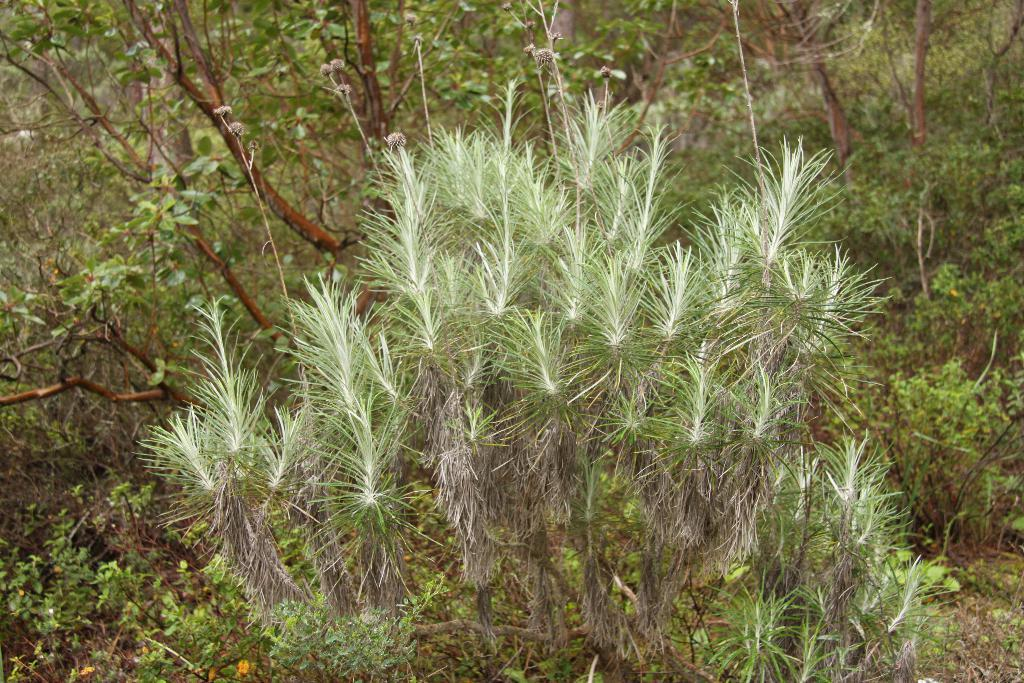What type of living organisms can be seen in the image? There are a few plants in the image. What type of government is depicted in the image? There is no government depicted in the image; it features a few plants. Is the dad mentioned or present in the image? There is no mention or presence of a dad in the image; it features a few plants. 